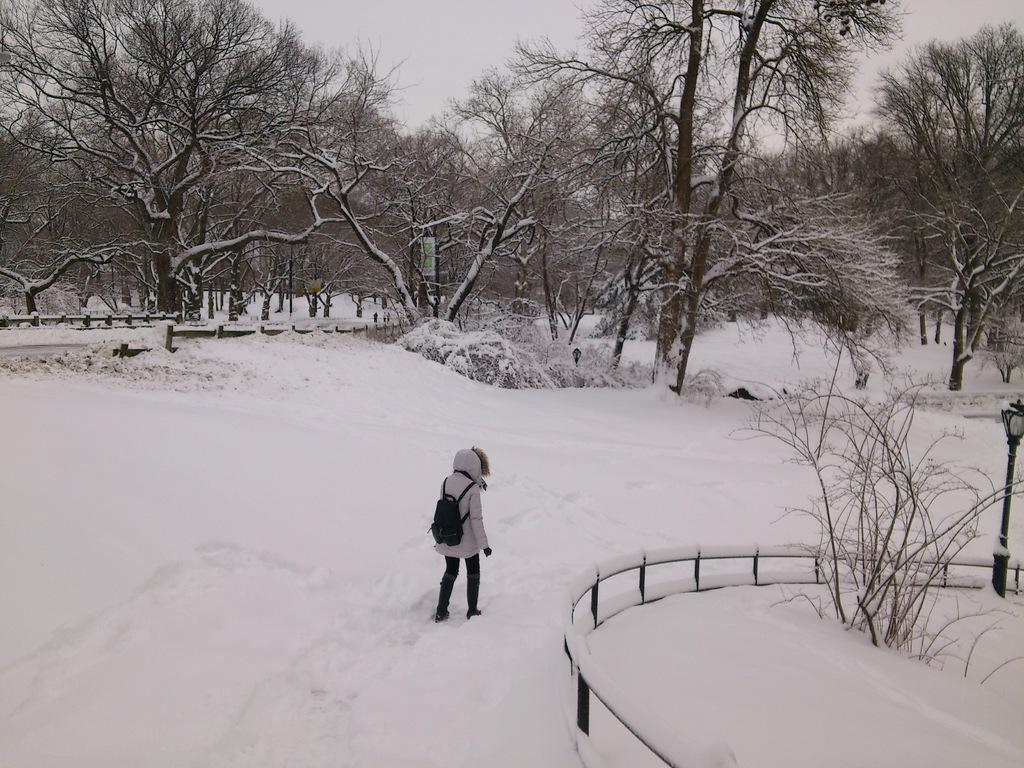What can be seen in the image? There is a person in the image, and they are walking on snow. What is the person wearing? The person is wearing a jacket and a backpack. What else is present in the image? There is a fencing, plants, trees, a light pole, and the sky is visible. What type of trouble is the committee facing in the image? There is no committee or trouble present in the image; it features a person walking on snow with various other elements. 